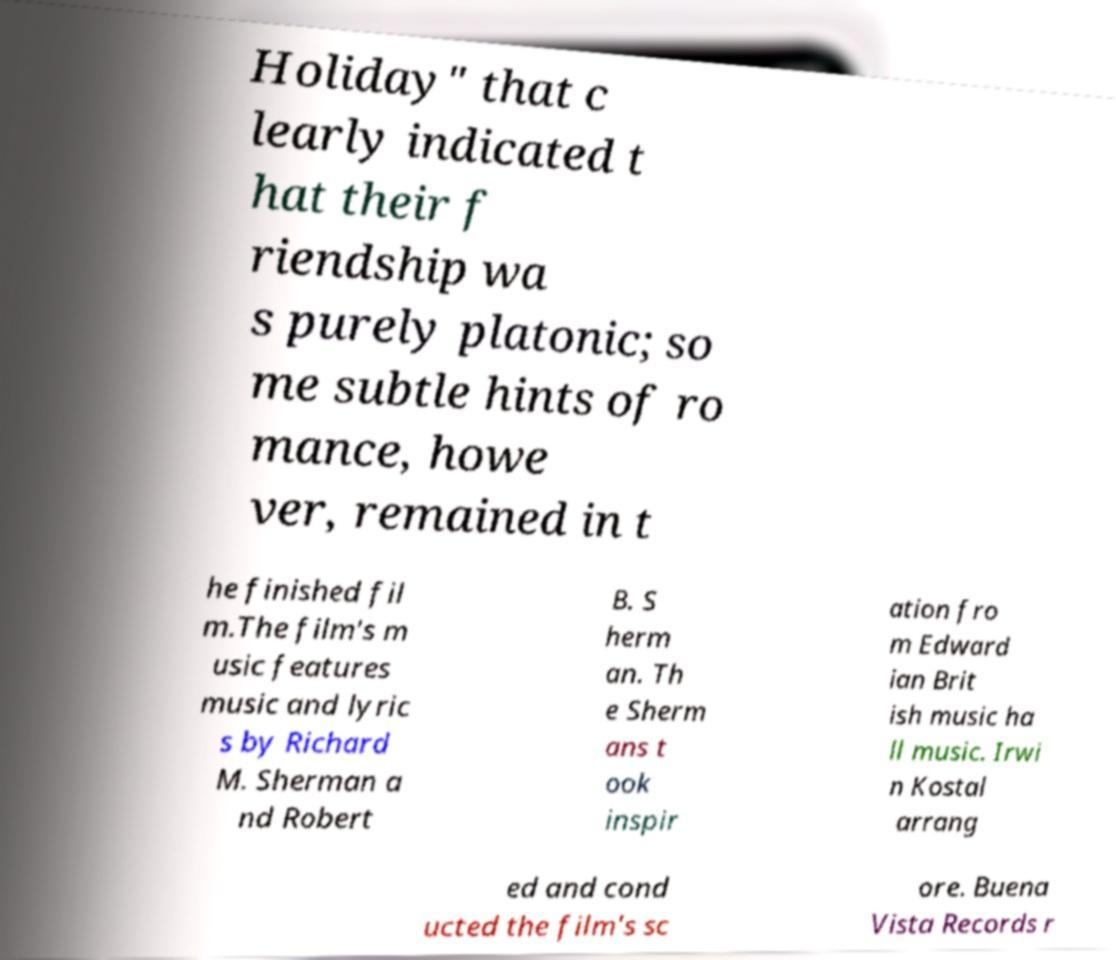I need the written content from this picture converted into text. Can you do that? Holiday" that c learly indicated t hat their f riendship wa s purely platonic; so me subtle hints of ro mance, howe ver, remained in t he finished fil m.The film's m usic features music and lyric s by Richard M. Sherman a nd Robert B. S herm an. Th e Sherm ans t ook inspir ation fro m Edward ian Brit ish music ha ll music. Irwi n Kostal arrang ed and cond ucted the film's sc ore. Buena Vista Records r 